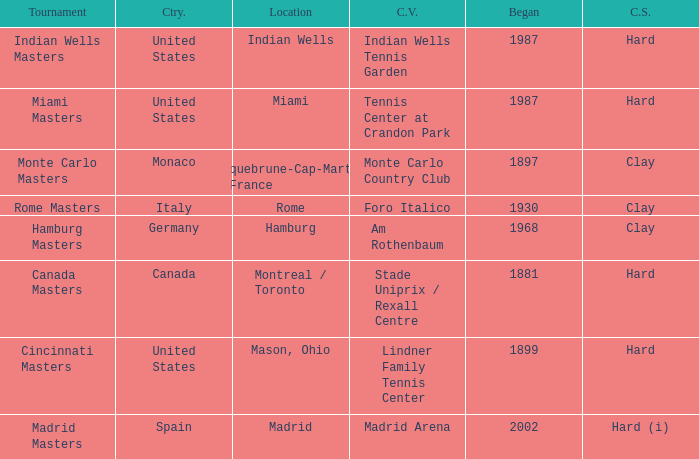What year was the tournament first held in Italy? 1930.0. Help me parse the entirety of this table. {'header': ['Tournament', 'Ctry.', 'Location', 'C.V.', 'Began', 'C.S.'], 'rows': [['Indian Wells Masters', 'United States', 'Indian Wells', 'Indian Wells Tennis Garden', '1987', 'Hard'], ['Miami Masters', 'United States', 'Miami', 'Tennis Center at Crandon Park', '1987', 'Hard'], ['Monte Carlo Masters', 'Monaco', 'Roquebrune-Cap-Martin , France', 'Monte Carlo Country Club', '1897', 'Clay'], ['Rome Masters', 'Italy', 'Rome', 'Foro Italico', '1930', 'Clay'], ['Hamburg Masters', 'Germany', 'Hamburg', 'Am Rothenbaum', '1968', 'Clay'], ['Canada Masters', 'Canada', 'Montreal / Toronto', 'Stade Uniprix / Rexall Centre', '1881', 'Hard'], ['Cincinnati Masters', 'United States', 'Mason, Ohio', 'Lindner Family Tennis Center', '1899', 'Hard'], ['Madrid Masters', 'Spain', 'Madrid', 'Madrid Arena', '2002', 'Hard (i)']]} 